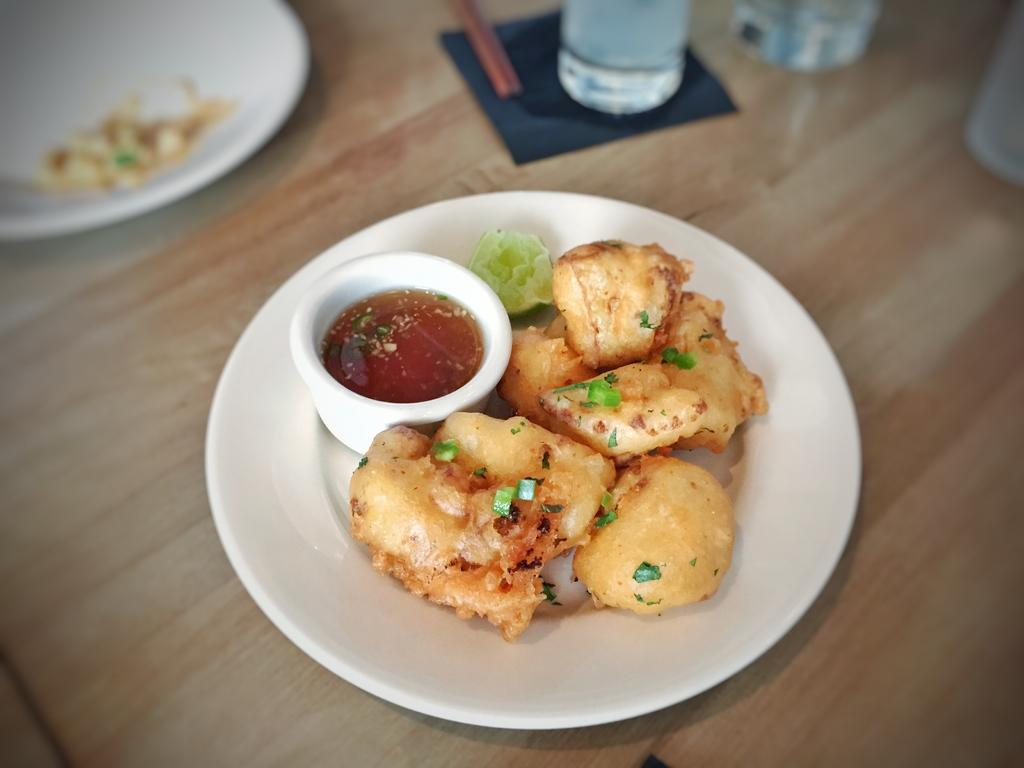What is on the plate that is visible in the image? There is food in a plate in the image. What else can be seen on the table in the image? There are glasses on the table in the image. Where is the sofa located in the image? There is no sofa present in the image. What type of school can be seen in the image? There is no school present in the image. 